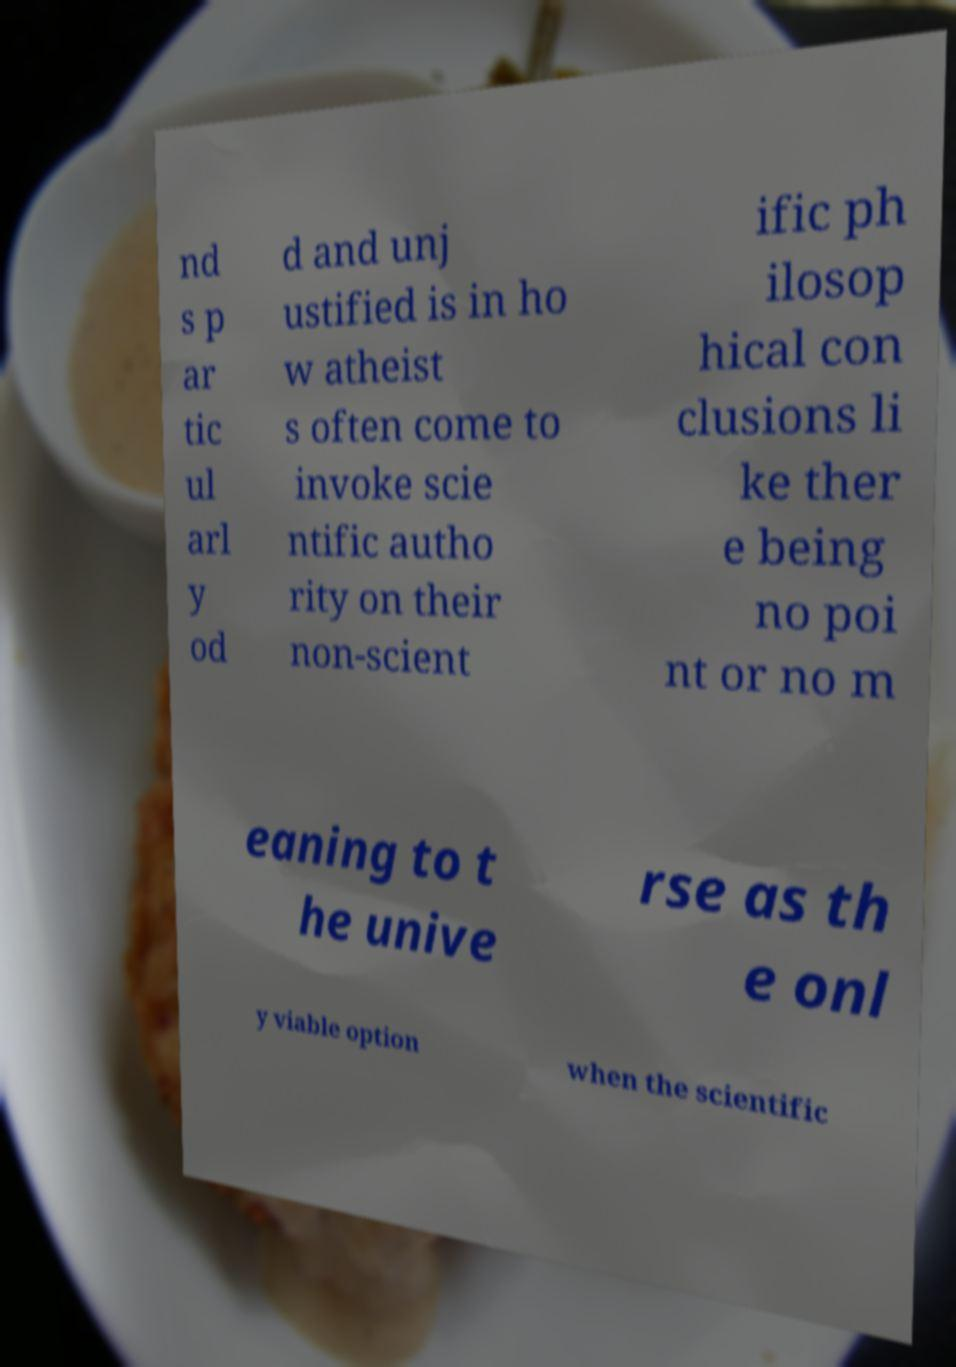Could you extract and type out the text from this image? nd s p ar tic ul arl y od d and unj ustified is in ho w atheist s often come to invoke scie ntific autho rity on their non-scient ific ph ilosop hical con clusions li ke ther e being no poi nt or no m eaning to t he unive rse as th e onl y viable option when the scientific 